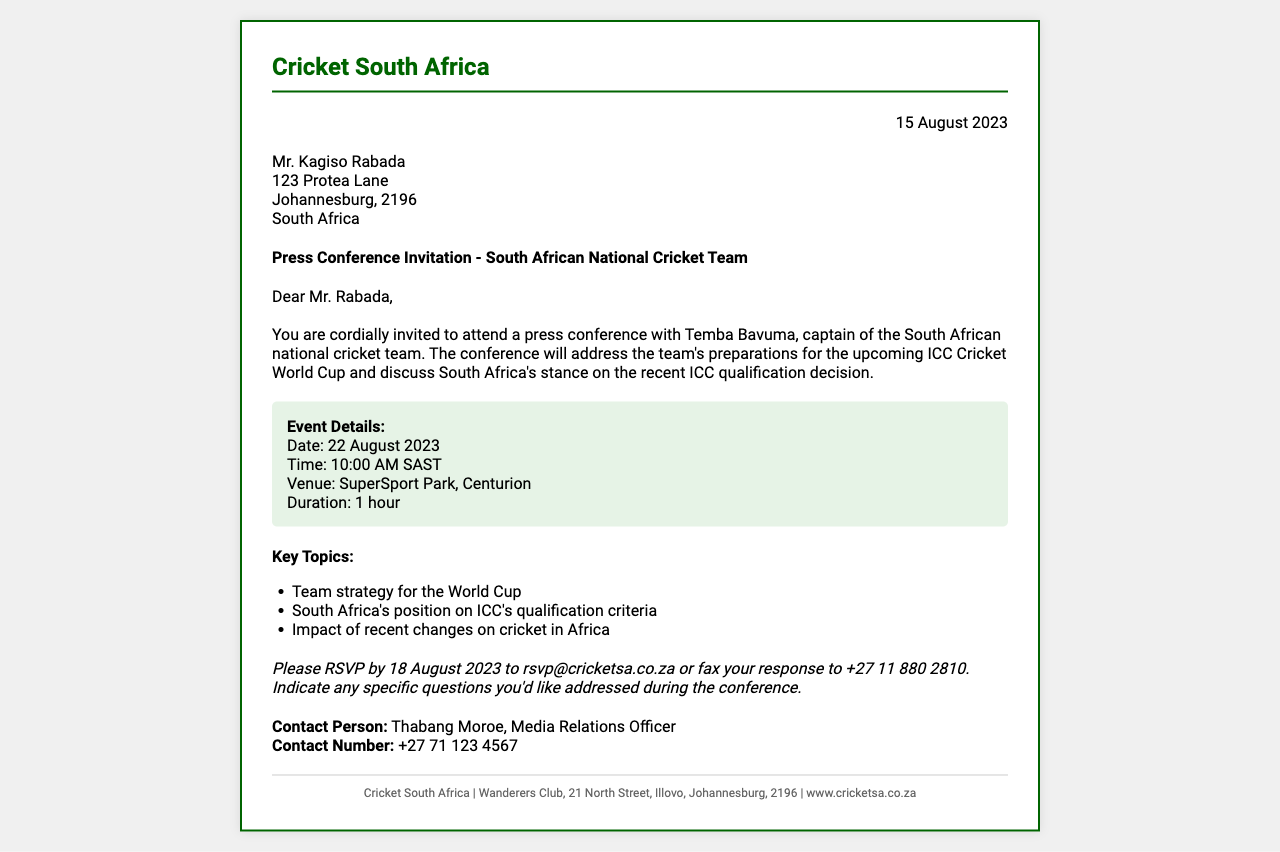What is the date of the press conference? The press conference is scheduled for 22 August 2023 as mentioned in the event details.
Answer: 22 August 2023 Who is the captain of the South African national cricket team? The letter indicates that Temba Bavuma is the captain of the team.
Answer: Temba Bavuma What is the venue of the press conference? The event details state that the press conference will take place at SuperSport Park, Centurion.
Answer: SuperSport Park, Centurion By what date should attendees RSVP? The RSVP deadline is clearly stated as 18 August 2023.
Answer: 18 August 2023 What are the key topics to be discussed? The document lists several key topics, including team strategy for the World Cup.
Answer: Team strategy for the World Cup What is the duration of the press conference? The event details outline that the press conference will last for 1 hour.
Answer: 1 hour Who should the attendees contact for more information? The contact person listed is Thabang Moroe, Media Relations Officer.
Answer: Thabang Moroe What email address should be used for RSVPs? The document provides the email for RSVPs as rsvp@cricketsa.co.za.
Answer: rsvp@cricketsa.co.za What is the contact number for the Media Relations Officer? The contact information provided for Thabang Moroe includes the number +27 71 123 4567.
Answer: +27 71 123 4567 